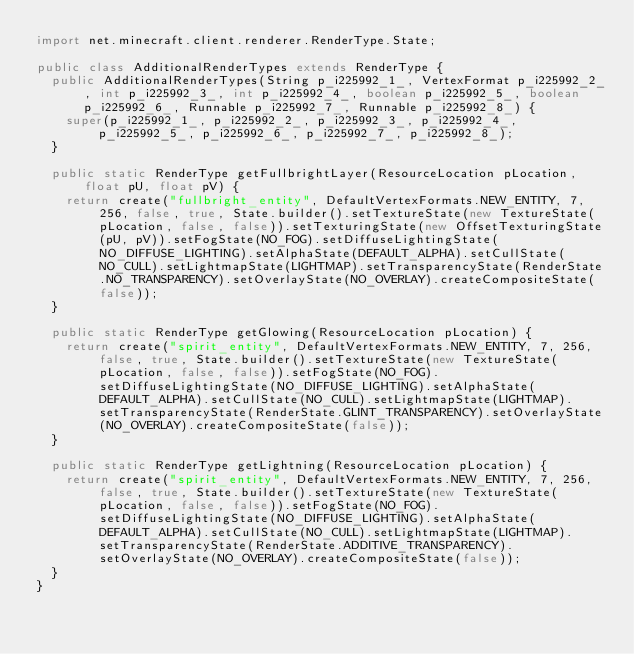<code> <loc_0><loc_0><loc_500><loc_500><_Java_>import net.minecraft.client.renderer.RenderType.State;

public class AdditionalRenderTypes extends RenderType {
  public AdditionalRenderTypes(String p_i225992_1_, VertexFormat p_i225992_2_, int p_i225992_3_, int p_i225992_4_, boolean p_i225992_5_, boolean p_i225992_6_, Runnable p_i225992_7_, Runnable p_i225992_8_) {
    super(p_i225992_1_, p_i225992_2_, p_i225992_3_, p_i225992_4_, p_i225992_5_, p_i225992_6_, p_i225992_7_, p_i225992_8_);
  }

  public static RenderType getFullbrightLayer(ResourceLocation pLocation, float pU, float pV) {
    return create("fullbright_entity", DefaultVertexFormats.NEW_ENTITY, 7, 256, false, true, State.builder().setTextureState(new TextureState(pLocation, false, false)).setTexturingState(new OffsetTexturingState(pU, pV)).setFogState(NO_FOG).setDiffuseLightingState(NO_DIFFUSE_LIGHTING).setAlphaState(DEFAULT_ALPHA).setCullState(NO_CULL).setLightmapState(LIGHTMAP).setTransparencyState(RenderState.NO_TRANSPARENCY).setOverlayState(NO_OVERLAY).createCompositeState(false));
  }

  public static RenderType getGlowing(ResourceLocation pLocation) {
    return create("spirit_entity", DefaultVertexFormats.NEW_ENTITY, 7, 256, false, true, State.builder().setTextureState(new TextureState(pLocation, false, false)).setFogState(NO_FOG).setDiffuseLightingState(NO_DIFFUSE_LIGHTING).setAlphaState(DEFAULT_ALPHA).setCullState(NO_CULL).setLightmapState(LIGHTMAP).setTransparencyState(RenderState.GLINT_TRANSPARENCY).setOverlayState(NO_OVERLAY).createCompositeState(false));
  }

  public static RenderType getLightning(ResourceLocation pLocation) {
    return create("spirit_entity", DefaultVertexFormats.NEW_ENTITY, 7, 256, false, true, State.builder().setTextureState(new TextureState(pLocation, false, false)).setFogState(NO_FOG).setDiffuseLightingState(NO_DIFFUSE_LIGHTING).setAlphaState(DEFAULT_ALPHA).setCullState(NO_CULL).setLightmapState(LIGHTMAP).setTransparencyState(RenderState.ADDITIVE_TRANSPARENCY).setOverlayState(NO_OVERLAY).createCompositeState(false));
  }
}
</code> 